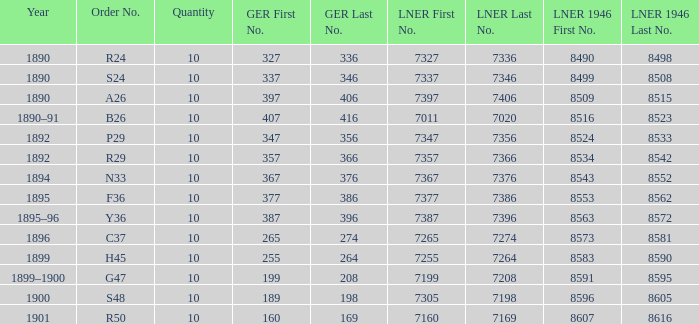Which LNER 1946 number is from 1892 and has an LNER number of 7347–7356? 8524–8533. 